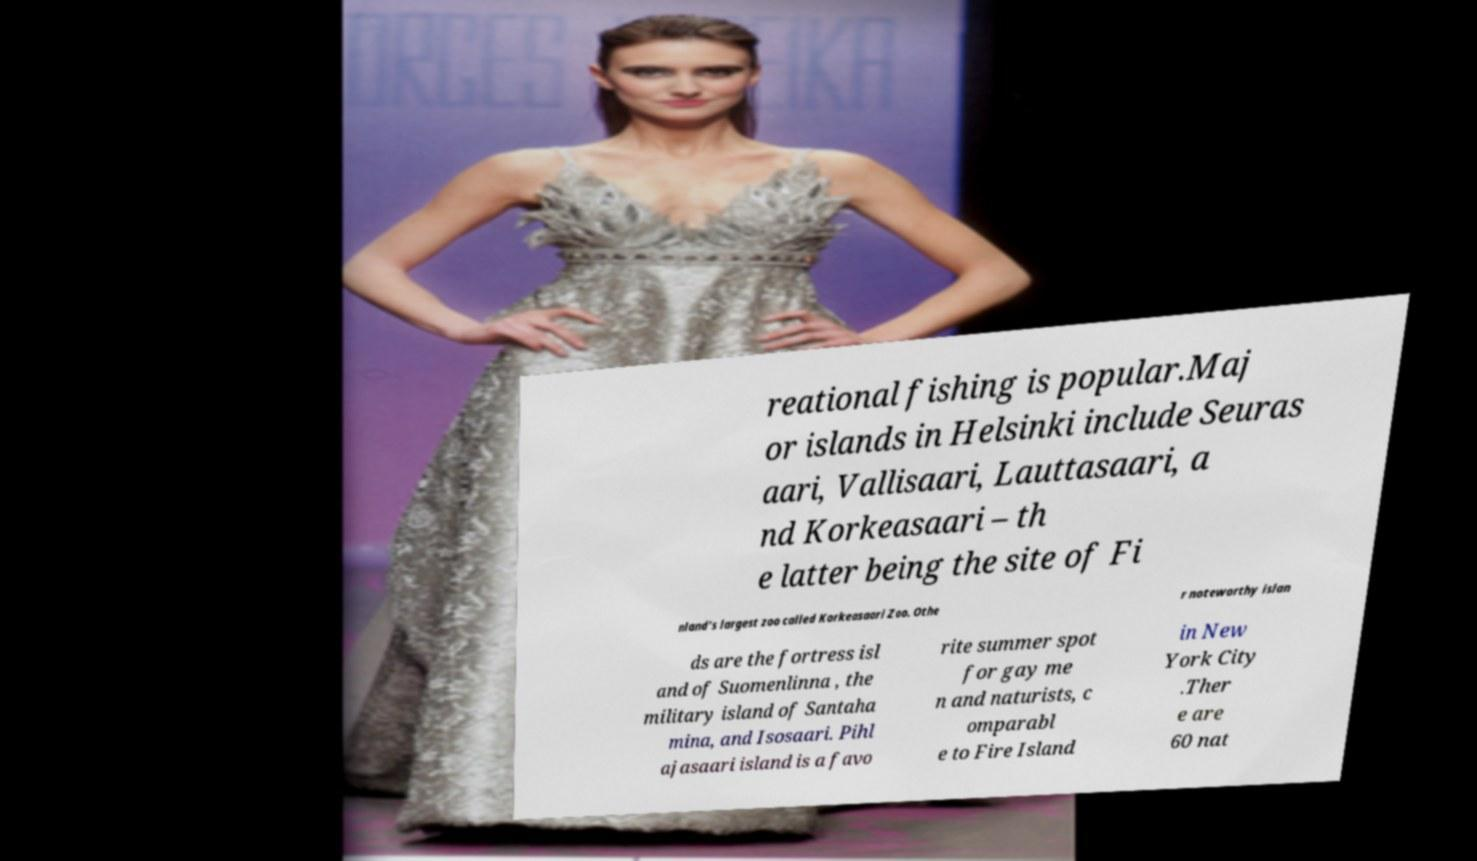Please read and relay the text visible in this image. What does it say? reational fishing is popular.Maj or islands in Helsinki include Seuras aari, Vallisaari, Lauttasaari, a nd Korkeasaari – th e latter being the site of Fi nland's largest zoo called Korkeasaari Zoo. Othe r noteworthy islan ds are the fortress isl and of Suomenlinna , the military island of Santaha mina, and Isosaari. Pihl ajasaari island is a favo rite summer spot for gay me n and naturists, c omparabl e to Fire Island in New York City .Ther e are 60 nat 